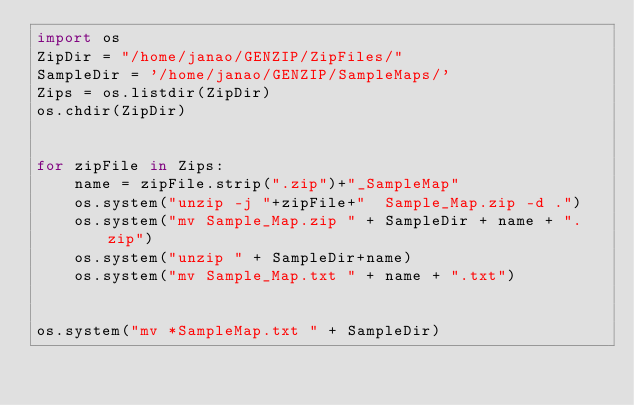<code> <loc_0><loc_0><loc_500><loc_500><_Python_>import os
ZipDir = "/home/janao/GENZIP/ZipFiles/"
SampleDir = '/home/janao/GENZIP/SampleMaps/'
Zips = os.listdir(ZipDir)
os.chdir(ZipDir)


for zipFile in Zips:
    name = zipFile.strip(".zip")+"_SampleMap"
    os.system("unzip -j "+zipFile+"  Sample_Map.zip -d .")
    os.system("mv Sample_Map.zip " + SampleDir + name + ".zip")
    os.system("unzip " + SampleDir+name)
    os.system("mv Sample_Map.txt " + name + ".txt")
    
    
os.system("mv *SampleMap.txt " + SampleDir)
    </code> 